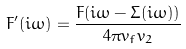Convert formula to latex. <formula><loc_0><loc_0><loc_500><loc_500>F ^ { \prime } ( i \omega ) = \frac { F ( i \omega - \Sigma ( i \omega ) ) } { 4 \pi v _ { f } v _ { 2 } }</formula> 